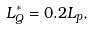<formula> <loc_0><loc_0><loc_500><loc_500>L _ { Q } ^ { * } = 0 . 2 L _ { p } ,</formula> 